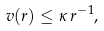Convert formula to latex. <formula><loc_0><loc_0><loc_500><loc_500>v ( r ) \leq \kappa \, r ^ { - 1 } ,</formula> 